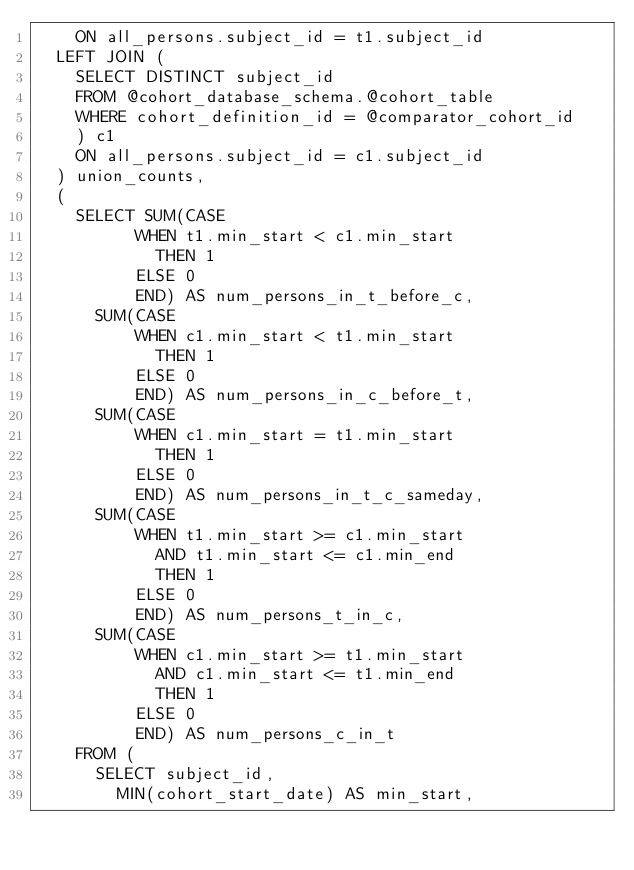<code> <loc_0><loc_0><loc_500><loc_500><_SQL_>		ON all_persons.subject_id = t1.subject_id
	LEFT JOIN (
		SELECT DISTINCT subject_id
		FROM @cohort_database_schema.@cohort_table
		WHERE cohort_definition_id = @comparator_cohort_id
		) c1
		ON all_persons.subject_id = c1.subject_id
	) union_counts,
	(
		SELECT SUM(CASE 
					WHEN t1.min_start < c1.min_start
						THEN 1
					ELSE 0
					END) AS num_persons_in_t_before_c,
			SUM(CASE 
					WHEN c1.min_start < t1.min_start
						THEN 1
					ELSE 0
					END) AS num_persons_in_c_before_t,
			SUM(CASE 
					WHEN c1.min_start = t1.min_start
						THEN 1
					ELSE 0
					END) AS num_persons_in_t_c_sameday,
			SUM(CASE 
					WHEN t1.min_start >= c1.min_start
						AND t1.min_start <= c1.min_end
						THEN 1
					ELSE 0
					END) AS num_persons_t_in_c,
			SUM(CASE 
					WHEN c1.min_start >= t1.min_start
						AND c1.min_start <= t1.min_end
						THEN 1
					ELSE 0
					END) AS num_persons_c_in_t
		FROM (
			SELECT subject_id,
				MIN(cohort_start_date) AS min_start,</code> 